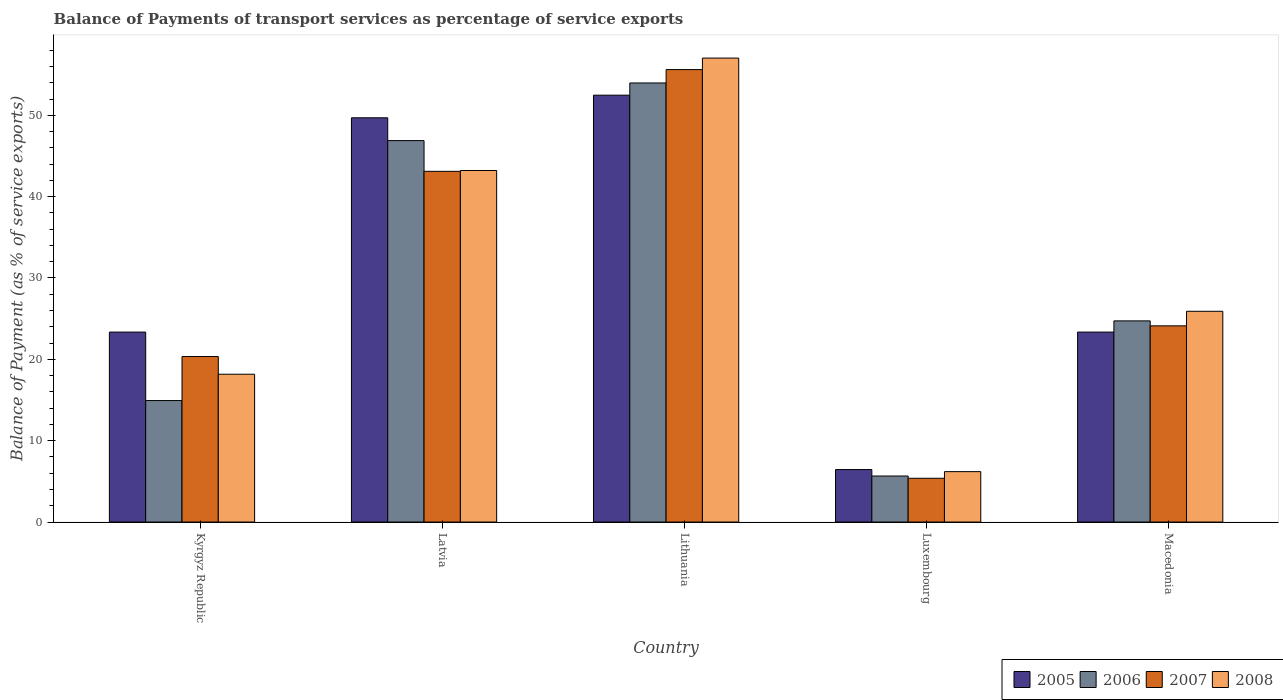How many different coloured bars are there?
Give a very brief answer. 4. How many groups of bars are there?
Your answer should be very brief. 5. Are the number of bars on each tick of the X-axis equal?
Ensure brevity in your answer.  Yes. How many bars are there on the 1st tick from the left?
Make the answer very short. 4. How many bars are there on the 3rd tick from the right?
Keep it short and to the point. 4. What is the label of the 3rd group of bars from the left?
Offer a very short reply. Lithuania. In how many cases, is the number of bars for a given country not equal to the number of legend labels?
Offer a very short reply. 0. What is the balance of payments of transport services in 2008 in Macedonia?
Your answer should be compact. 25.91. Across all countries, what is the maximum balance of payments of transport services in 2006?
Provide a short and direct response. 53.97. Across all countries, what is the minimum balance of payments of transport services in 2007?
Make the answer very short. 5.38. In which country was the balance of payments of transport services in 2008 maximum?
Ensure brevity in your answer.  Lithuania. In which country was the balance of payments of transport services in 2006 minimum?
Your response must be concise. Luxembourg. What is the total balance of payments of transport services in 2006 in the graph?
Provide a short and direct response. 146.18. What is the difference between the balance of payments of transport services in 2008 in Lithuania and that in Macedonia?
Your response must be concise. 31.13. What is the difference between the balance of payments of transport services in 2008 in Luxembourg and the balance of payments of transport services in 2005 in Kyrgyz Republic?
Make the answer very short. -17.15. What is the average balance of payments of transport services in 2005 per country?
Ensure brevity in your answer.  31.06. What is the difference between the balance of payments of transport services of/in 2007 and balance of payments of transport services of/in 2005 in Kyrgyz Republic?
Keep it short and to the point. -3. In how many countries, is the balance of payments of transport services in 2007 greater than 2 %?
Keep it short and to the point. 5. What is the ratio of the balance of payments of transport services in 2007 in Kyrgyz Republic to that in Latvia?
Give a very brief answer. 0.47. What is the difference between the highest and the second highest balance of payments of transport services in 2005?
Your answer should be compact. -2.78. What is the difference between the highest and the lowest balance of payments of transport services in 2007?
Your answer should be compact. 50.24. What does the 3rd bar from the left in Kyrgyz Republic represents?
Provide a short and direct response. 2007. How many bars are there?
Provide a succinct answer. 20. Are all the bars in the graph horizontal?
Your answer should be compact. No. How many countries are there in the graph?
Provide a succinct answer. 5. What is the difference between two consecutive major ticks on the Y-axis?
Your answer should be compact. 10. Are the values on the major ticks of Y-axis written in scientific E-notation?
Offer a terse response. No. How many legend labels are there?
Offer a terse response. 4. How are the legend labels stacked?
Give a very brief answer. Horizontal. What is the title of the graph?
Provide a short and direct response. Balance of Payments of transport services as percentage of service exports. What is the label or title of the X-axis?
Your answer should be compact. Country. What is the label or title of the Y-axis?
Offer a terse response. Balance of Payment (as % of service exports). What is the Balance of Payment (as % of service exports) in 2005 in Kyrgyz Republic?
Offer a very short reply. 23.35. What is the Balance of Payment (as % of service exports) of 2006 in Kyrgyz Republic?
Ensure brevity in your answer.  14.93. What is the Balance of Payment (as % of service exports) of 2007 in Kyrgyz Republic?
Make the answer very short. 20.34. What is the Balance of Payment (as % of service exports) of 2008 in Kyrgyz Republic?
Your answer should be compact. 18.17. What is the Balance of Payment (as % of service exports) in 2005 in Latvia?
Provide a short and direct response. 49.69. What is the Balance of Payment (as % of service exports) in 2006 in Latvia?
Provide a short and direct response. 46.89. What is the Balance of Payment (as % of service exports) in 2007 in Latvia?
Provide a short and direct response. 43.11. What is the Balance of Payment (as % of service exports) of 2008 in Latvia?
Make the answer very short. 43.21. What is the Balance of Payment (as % of service exports) in 2005 in Lithuania?
Offer a terse response. 52.47. What is the Balance of Payment (as % of service exports) of 2006 in Lithuania?
Offer a terse response. 53.97. What is the Balance of Payment (as % of service exports) of 2007 in Lithuania?
Make the answer very short. 55.62. What is the Balance of Payment (as % of service exports) in 2008 in Lithuania?
Your answer should be compact. 57.03. What is the Balance of Payment (as % of service exports) in 2005 in Luxembourg?
Your response must be concise. 6.45. What is the Balance of Payment (as % of service exports) of 2006 in Luxembourg?
Give a very brief answer. 5.66. What is the Balance of Payment (as % of service exports) in 2007 in Luxembourg?
Offer a terse response. 5.38. What is the Balance of Payment (as % of service exports) in 2008 in Luxembourg?
Offer a terse response. 6.2. What is the Balance of Payment (as % of service exports) of 2005 in Macedonia?
Offer a terse response. 23.35. What is the Balance of Payment (as % of service exports) in 2006 in Macedonia?
Your answer should be compact. 24.73. What is the Balance of Payment (as % of service exports) of 2007 in Macedonia?
Offer a very short reply. 24.12. What is the Balance of Payment (as % of service exports) in 2008 in Macedonia?
Your answer should be very brief. 25.91. Across all countries, what is the maximum Balance of Payment (as % of service exports) of 2005?
Your answer should be very brief. 52.47. Across all countries, what is the maximum Balance of Payment (as % of service exports) of 2006?
Your answer should be compact. 53.97. Across all countries, what is the maximum Balance of Payment (as % of service exports) of 2007?
Give a very brief answer. 55.62. Across all countries, what is the maximum Balance of Payment (as % of service exports) of 2008?
Offer a terse response. 57.03. Across all countries, what is the minimum Balance of Payment (as % of service exports) in 2005?
Offer a terse response. 6.45. Across all countries, what is the minimum Balance of Payment (as % of service exports) of 2006?
Your response must be concise. 5.66. Across all countries, what is the minimum Balance of Payment (as % of service exports) in 2007?
Your answer should be compact. 5.38. Across all countries, what is the minimum Balance of Payment (as % of service exports) in 2008?
Provide a succinct answer. 6.2. What is the total Balance of Payment (as % of service exports) of 2005 in the graph?
Your answer should be very brief. 155.31. What is the total Balance of Payment (as % of service exports) in 2006 in the graph?
Ensure brevity in your answer.  146.18. What is the total Balance of Payment (as % of service exports) of 2007 in the graph?
Your response must be concise. 148.57. What is the total Balance of Payment (as % of service exports) in 2008 in the graph?
Provide a succinct answer. 150.51. What is the difference between the Balance of Payment (as % of service exports) in 2005 in Kyrgyz Republic and that in Latvia?
Make the answer very short. -26.34. What is the difference between the Balance of Payment (as % of service exports) of 2006 in Kyrgyz Republic and that in Latvia?
Provide a succinct answer. -31.95. What is the difference between the Balance of Payment (as % of service exports) of 2007 in Kyrgyz Republic and that in Latvia?
Your answer should be very brief. -22.76. What is the difference between the Balance of Payment (as % of service exports) of 2008 in Kyrgyz Republic and that in Latvia?
Keep it short and to the point. -25.04. What is the difference between the Balance of Payment (as % of service exports) in 2005 in Kyrgyz Republic and that in Lithuania?
Your response must be concise. -29.12. What is the difference between the Balance of Payment (as % of service exports) of 2006 in Kyrgyz Republic and that in Lithuania?
Ensure brevity in your answer.  -39.04. What is the difference between the Balance of Payment (as % of service exports) of 2007 in Kyrgyz Republic and that in Lithuania?
Keep it short and to the point. -35.27. What is the difference between the Balance of Payment (as % of service exports) of 2008 in Kyrgyz Republic and that in Lithuania?
Keep it short and to the point. -38.86. What is the difference between the Balance of Payment (as % of service exports) of 2005 in Kyrgyz Republic and that in Luxembourg?
Ensure brevity in your answer.  16.9. What is the difference between the Balance of Payment (as % of service exports) of 2006 in Kyrgyz Republic and that in Luxembourg?
Offer a terse response. 9.28. What is the difference between the Balance of Payment (as % of service exports) in 2007 in Kyrgyz Republic and that in Luxembourg?
Ensure brevity in your answer.  14.97. What is the difference between the Balance of Payment (as % of service exports) in 2008 in Kyrgyz Republic and that in Luxembourg?
Your response must be concise. 11.97. What is the difference between the Balance of Payment (as % of service exports) of 2005 in Kyrgyz Republic and that in Macedonia?
Keep it short and to the point. -0. What is the difference between the Balance of Payment (as % of service exports) of 2006 in Kyrgyz Republic and that in Macedonia?
Offer a very short reply. -9.79. What is the difference between the Balance of Payment (as % of service exports) of 2007 in Kyrgyz Republic and that in Macedonia?
Ensure brevity in your answer.  -3.77. What is the difference between the Balance of Payment (as % of service exports) of 2008 in Kyrgyz Republic and that in Macedonia?
Give a very brief answer. -7.74. What is the difference between the Balance of Payment (as % of service exports) in 2005 in Latvia and that in Lithuania?
Make the answer very short. -2.78. What is the difference between the Balance of Payment (as % of service exports) in 2006 in Latvia and that in Lithuania?
Offer a very short reply. -7.09. What is the difference between the Balance of Payment (as % of service exports) in 2007 in Latvia and that in Lithuania?
Your answer should be very brief. -12.51. What is the difference between the Balance of Payment (as % of service exports) of 2008 in Latvia and that in Lithuania?
Give a very brief answer. -13.82. What is the difference between the Balance of Payment (as % of service exports) in 2005 in Latvia and that in Luxembourg?
Your response must be concise. 43.24. What is the difference between the Balance of Payment (as % of service exports) in 2006 in Latvia and that in Luxembourg?
Make the answer very short. 41.23. What is the difference between the Balance of Payment (as % of service exports) in 2007 in Latvia and that in Luxembourg?
Your response must be concise. 37.73. What is the difference between the Balance of Payment (as % of service exports) of 2008 in Latvia and that in Luxembourg?
Offer a very short reply. 37.02. What is the difference between the Balance of Payment (as % of service exports) of 2005 in Latvia and that in Macedonia?
Offer a terse response. 26.34. What is the difference between the Balance of Payment (as % of service exports) of 2006 in Latvia and that in Macedonia?
Offer a terse response. 22.16. What is the difference between the Balance of Payment (as % of service exports) in 2007 in Latvia and that in Macedonia?
Provide a short and direct response. 18.99. What is the difference between the Balance of Payment (as % of service exports) of 2008 in Latvia and that in Macedonia?
Make the answer very short. 17.31. What is the difference between the Balance of Payment (as % of service exports) of 2005 in Lithuania and that in Luxembourg?
Your answer should be compact. 46.02. What is the difference between the Balance of Payment (as % of service exports) in 2006 in Lithuania and that in Luxembourg?
Ensure brevity in your answer.  48.32. What is the difference between the Balance of Payment (as % of service exports) of 2007 in Lithuania and that in Luxembourg?
Your answer should be very brief. 50.24. What is the difference between the Balance of Payment (as % of service exports) of 2008 in Lithuania and that in Luxembourg?
Your answer should be very brief. 50.84. What is the difference between the Balance of Payment (as % of service exports) of 2005 in Lithuania and that in Macedonia?
Offer a very short reply. 29.12. What is the difference between the Balance of Payment (as % of service exports) of 2006 in Lithuania and that in Macedonia?
Provide a short and direct response. 29.25. What is the difference between the Balance of Payment (as % of service exports) in 2007 in Lithuania and that in Macedonia?
Give a very brief answer. 31.5. What is the difference between the Balance of Payment (as % of service exports) of 2008 in Lithuania and that in Macedonia?
Ensure brevity in your answer.  31.13. What is the difference between the Balance of Payment (as % of service exports) in 2005 in Luxembourg and that in Macedonia?
Your answer should be compact. -16.9. What is the difference between the Balance of Payment (as % of service exports) in 2006 in Luxembourg and that in Macedonia?
Offer a very short reply. -19.07. What is the difference between the Balance of Payment (as % of service exports) in 2007 in Luxembourg and that in Macedonia?
Give a very brief answer. -18.74. What is the difference between the Balance of Payment (as % of service exports) of 2008 in Luxembourg and that in Macedonia?
Your answer should be compact. -19.71. What is the difference between the Balance of Payment (as % of service exports) in 2005 in Kyrgyz Republic and the Balance of Payment (as % of service exports) in 2006 in Latvia?
Offer a terse response. -23.54. What is the difference between the Balance of Payment (as % of service exports) of 2005 in Kyrgyz Republic and the Balance of Payment (as % of service exports) of 2007 in Latvia?
Offer a very short reply. -19.76. What is the difference between the Balance of Payment (as % of service exports) of 2005 in Kyrgyz Republic and the Balance of Payment (as % of service exports) of 2008 in Latvia?
Keep it short and to the point. -19.86. What is the difference between the Balance of Payment (as % of service exports) in 2006 in Kyrgyz Republic and the Balance of Payment (as % of service exports) in 2007 in Latvia?
Your answer should be very brief. -28.18. What is the difference between the Balance of Payment (as % of service exports) in 2006 in Kyrgyz Republic and the Balance of Payment (as % of service exports) in 2008 in Latvia?
Provide a short and direct response. -28.28. What is the difference between the Balance of Payment (as % of service exports) in 2007 in Kyrgyz Republic and the Balance of Payment (as % of service exports) in 2008 in Latvia?
Your answer should be compact. -22.87. What is the difference between the Balance of Payment (as % of service exports) of 2005 in Kyrgyz Republic and the Balance of Payment (as % of service exports) of 2006 in Lithuania?
Offer a very short reply. -30.62. What is the difference between the Balance of Payment (as % of service exports) in 2005 in Kyrgyz Republic and the Balance of Payment (as % of service exports) in 2007 in Lithuania?
Offer a terse response. -32.27. What is the difference between the Balance of Payment (as % of service exports) in 2005 in Kyrgyz Republic and the Balance of Payment (as % of service exports) in 2008 in Lithuania?
Provide a short and direct response. -33.68. What is the difference between the Balance of Payment (as % of service exports) in 2006 in Kyrgyz Republic and the Balance of Payment (as % of service exports) in 2007 in Lithuania?
Your answer should be very brief. -40.68. What is the difference between the Balance of Payment (as % of service exports) in 2006 in Kyrgyz Republic and the Balance of Payment (as % of service exports) in 2008 in Lithuania?
Give a very brief answer. -42.1. What is the difference between the Balance of Payment (as % of service exports) in 2007 in Kyrgyz Republic and the Balance of Payment (as % of service exports) in 2008 in Lithuania?
Make the answer very short. -36.69. What is the difference between the Balance of Payment (as % of service exports) in 2005 in Kyrgyz Republic and the Balance of Payment (as % of service exports) in 2006 in Luxembourg?
Give a very brief answer. 17.69. What is the difference between the Balance of Payment (as % of service exports) of 2005 in Kyrgyz Republic and the Balance of Payment (as % of service exports) of 2007 in Luxembourg?
Keep it short and to the point. 17.97. What is the difference between the Balance of Payment (as % of service exports) of 2005 in Kyrgyz Republic and the Balance of Payment (as % of service exports) of 2008 in Luxembourg?
Your response must be concise. 17.15. What is the difference between the Balance of Payment (as % of service exports) of 2006 in Kyrgyz Republic and the Balance of Payment (as % of service exports) of 2007 in Luxembourg?
Offer a terse response. 9.55. What is the difference between the Balance of Payment (as % of service exports) in 2006 in Kyrgyz Republic and the Balance of Payment (as % of service exports) in 2008 in Luxembourg?
Your response must be concise. 8.74. What is the difference between the Balance of Payment (as % of service exports) of 2007 in Kyrgyz Republic and the Balance of Payment (as % of service exports) of 2008 in Luxembourg?
Provide a succinct answer. 14.15. What is the difference between the Balance of Payment (as % of service exports) in 2005 in Kyrgyz Republic and the Balance of Payment (as % of service exports) in 2006 in Macedonia?
Your answer should be compact. -1.38. What is the difference between the Balance of Payment (as % of service exports) in 2005 in Kyrgyz Republic and the Balance of Payment (as % of service exports) in 2007 in Macedonia?
Keep it short and to the point. -0.77. What is the difference between the Balance of Payment (as % of service exports) of 2005 in Kyrgyz Republic and the Balance of Payment (as % of service exports) of 2008 in Macedonia?
Keep it short and to the point. -2.56. What is the difference between the Balance of Payment (as % of service exports) of 2006 in Kyrgyz Republic and the Balance of Payment (as % of service exports) of 2007 in Macedonia?
Ensure brevity in your answer.  -9.18. What is the difference between the Balance of Payment (as % of service exports) of 2006 in Kyrgyz Republic and the Balance of Payment (as % of service exports) of 2008 in Macedonia?
Offer a very short reply. -10.97. What is the difference between the Balance of Payment (as % of service exports) in 2007 in Kyrgyz Republic and the Balance of Payment (as % of service exports) in 2008 in Macedonia?
Provide a succinct answer. -5.56. What is the difference between the Balance of Payment (as % of service exports) of 2005 in Latvia and the Balance of Payment (as % of service exports) of 2006 in Lithuania?
Your answer should be very brief. -4.28. What is the difference between the Balance of Payment (as % of service exports) of 2005 in Latvia and the Balance of Payment (as % of service exports) of 2007 in Lithuania?
Your answer should be compact. -5.93. What is the difference between the Balance of Payment (as % of service exports) in 2005 in Latvia and the Balance of Payment (as % of service exports) in 2008 in Lithuania?
Offer a terse response. -7.34. What is the difference between the Balance of Payment (as % of service exports) in 2006 in Latvia and the Balance of Payment (as % of service exports) in 2007 in Lithuania?
Offer a terse response. -8.73. What is the difference between the Balance of Payment (as % of service exports) of 2006 in Latvia and the Balance of Payment (as % of service exports) of 2008 in Lithuania?
Offer a very short reply. -10.14. What is the difference between the Balance of Payment (as % of service exports) of 2007 in Latvia and the Balance of Payment (as % of service exports) of 2008 in Lithuania?
Make the answer very short. -13.92. What is the difference between the Balance of Payment (as % of service exports) of 2005 in Latvia and the Balance of Payment (as % of service exports) of 2006 in Luxembourg?
Ensure brevity in your answer.  44.04. What is the difference between the Balance of Payment (as % of service exports) in 2005 in Latvia and the Balance of Payment (as % of service exports) in 2007 in Luxembourg?
Your answer should be very brief. 44.31. What is the difference between the Balance of Payment (as % of service exports) of 2005 in Latvia and the Balance of Payment (as % of service exports) of 2008 in Luxembourg?
Provide a succinct answer. 43.5. What is the difference between the Balance of Payment (as % of service exports) of 2006 in Latvia and the Balance of Payment (as % of service exports) of 2007 in Luxembourg?
Your answer should be very brief. 41.51. What is the difference between the Balance of Payment (as % of service exports) of 2006 in Latvia and the Balance of Payment (as % of service exports) of 2008 in Luxembourg?
Ensure brevity in your answer.  40.69. What is the difference between the Balance of Payment (as % of service exports) in 2007 in Latvia and the Balance of Payment (as % of service exports) in 2008 in Luxembourg?
Provide a short and direct response. 36.91. What is the difference between the Balance of Payment (as % of service exports) of 2005 in Latvia and the Balance of Payment (as % of service exports) of 2006 in Macedonia?
Keep it short and to the point. 24.96. What is the difference between the Balance of Payment (as % of service exports) of 2005 in Latvia and the Balance of Payment (as % of service exports) of 2007 in Macedonia?
Ensure brevity in your answer.  25.58. What is the difference between the Balance of Payment (as % of service exports) in 2005 in Latvia and the Balance of Payment (as % of service exports) in 2008 in Macedonia?
Make the answer very short. 23.79. What is the difference between the Balance of Payment (as % of service exports) in 2006 in Latvia and the Balance of Payment (as % of service exports) in 2007 in Macedonia?
Make the answer very short. 22.77. What is the difference between the Balance of Payment (as % of service exports) in 2006 in Latvia and the Balance of Payment (as % of service exports) in 2008 in Macedonia?
Give a very brief answer. 20.98. What is the difference between the Balance of Payment (as % of service exports) in 2007 in Latvia and the Balance of Payment (as % of service exports) in 2008 in Macedonia?
Keep it short and to the point. 17.2. What is the difference between the Balance of Payment (as % of service exports) in 2005 in Lithuania and the Balance of Payment (as % of service exports) in 2006 in Luxembourg?
Provide a succinct answer. 46.82. What is the difference between the Balance of Payment (as % of service exports) in 2005 in Lithuania and the Balance of Payment (as % of service exports) in 2007 in Luxembourg?
Offer a very short reply. 47.09. What is the difference between the Balance of Payment (as % of service exports) of 2005 in Lithuania and the Balance of Payment (as % of service exports) of 2008 in Luxembourg?
Your response must be concise. 46.27. What is the difference between the Balance of Payment (as % of service exports) of 2006 in Lithuania and the Balance of Payment (as % of service exports) of 2007 in Luxembourg?
Make the answer very short. 48.59. What is the difference between the Balance of Payment (as % of service exports) of 2006 in Lithuania and the Balance of Payment (as % of service exports) of 2008 in Luxembourg?
Your answer should be compact. 47.78. What is the difference between the Balance of Payment (as % of service exports) in 2007 in Lithuania and the Balance of Payment (as % of service exports) in 2008 in Luxembourg?
Your response must be concise. 49.42. What is the difference between the Balance of Payment (as % of service exports) of 2005 in Lithuania and the Balance of Payment (as % of service exports) of 2006 in Macedonia?
Ensure brevity in your answer.  27.74. What is the difference between the Balance of Payment (as % of service exports) of 2005 in Lithuania and the Balance of Payment (as % of service exports) of 2007 in Macedonia?
Provide a short and direct response. 28.36. What is the difference between the Balance of Payment (as % of service exports) of 2005 in Lithuania and the Balance of Payment (as % of service exports) of 2008 in Macedonia?
Your answer should be very brief. 26.57. What is the difference between the Balance of Payment (as % of service exports) of 2006 in Lithuania and the Balance of Payment (as % of service exports) of 2007 in Macedonia?
Offer a very short reply. 29.86. What is the difference between the Balance of Payment (as % of service exports) in 2006 in Lithuania and the Balance of Payment (as % of service exports) in 2008 in Macedonia?
Offer a very short reply. 28.07. What is the difference between the Balance of Payment (as % of service exports) in 2007 in Lithuania and the Balance of Payment (as % of service exports) in 2008 in Macedonia?
Make the answer very short. 29.71. What is the difference between the Balance of Payment (as % of service exports) of 2005 in Luxembourg and the Balance of Payment (as % of service exports) of 2006 in Macedonia?
Keep it short and to the point. -18.28. What is the difference between the Balance of Payment (as % of service exports) of 2005 in Luxembourg and the Balance of Payment (as % of service exports) of 2007 in Macedonia?
Your response must be concise. -17.66. What is the difference between the Balance of Payment (as % of service exports) in 2005 in Luxembourg and the Balance of Payment (as % of service exports) in 2008 in Macedonia?
Provide a short and direct response. -19.45. What is the difference between the Balance of Payment (as % of service exports) of 2006 in Luxembourg and the Balance of Payment (as % of service exports) of 2007 in Macedonia?
Your answer should be very brief. -18.46. What is the difference between the Balance of Payment (as % of service exports) of 2006 in Luxembourg and the Balance of Payment (as % of service exports) of 2008 in Macedonia?
Your response must be concise. -20.25. What is the difference between the Balance of Payment (as % of service exports) of 2007 in Luxembourg and the Balance of Payment (as % of service exports) of 2008 in Macedonia?
Offer a terse response. -20.53. What is the average Balance of Payment (as % of service exports) in 2005 per country?
Offer a very short reply. 31.06. What is the average Balance of Payment (as % of service exports) in 2006 per country?
Your response must be concise. 29.24. What is the average Balance of Payment (as % of service exports) in 2007 per country?
Provide a succinct answer. 29.71. What is the average Balance of Payment (as % of service exports) of 2008 per country?
Make the answer very short. 30.1. What is the difference between the Balance of Payment (as % of service exports) in 2005 and Balance of Payment (as % of service exports) in 2006 in Kyrgyz Republic?
Offer a terse response. 8.42. What is the difference between the Balance of Payment (as % of service exports) in 2005 and Balance of Payment (as % of service exports) in 2007 in Kyrgyz Republic?
Offer a very short reply. 3. What is the difference between the Balance of Payment (as % of service exports) in 2005 and Balance of Payment (as % of service exports) in 2008 in Kyrgyz Republic?
Provide a succinct answer. 5.18. What is the difference between the Balance of Payment (as % of service exports) of 2006 and Balance of Payment (as % of service exports) of 2007 in Kyrgyz Republic?
Provide a succinct answer. -5.41. What is the difference between the Balance of Payment (as % of service exports) in 2006 and Balance of Payment (as % of service exports) in 2008 in Kyrgyz Republic?
Offer a terse response. -3.24. What is the difference between the Balance of Payment (as % of service exports) in 2007 and Balance of Payment (as % of service exports) in 2008 in Kyrgyz Republic?
Make the answer very short. 2.18. What is the difference between the Balance of Payment (as % of service exports) of 2005 and Balance of Payment (as % of service exports) of 2006 in Latvia?
Ensure brevity in your answer.  2.8. What is the difference between the Balance of Payment (as % of service exports) of 2005 and Balance of Payment (as % of service exports) of 2007 in Latvia?
Your answer should be very brief. 6.58. What is the difference between the Balance of Payment (as % of service exports) in 2005 and Balance of Payment (as % of service exports) in 2008 in Latvia?
Keep it short and to the point. 6.48. What is the difference between the Balance of Payment (as % of service exports) in 2006 and Balance of Payment (as % of service exports) in 2007 in Latvia?
Offer a terse response. 3.78. What is the difference between the Balance of Payment (as % of service exports) in 2006 and Balance of Payment (as % of service exports) in 2008 in Latvia?
Provide a short and direct response. 3.67. What is the difference between the Balance of Payment (as % of service exports) in 2007 and Balance of Payment (as % of service exports) in 2008 in Latvia?
Your answer should be very brief. -0.1. What is the difference between the Balance of Payment (as % of service exports) in 2005 and Balance of Payment (as % of service exports) in 2006 in Lithuania?
Your response must be concise. -1.5. What is the difference between the Balance of Payment (as % of service exports) of 2005 and Balance of Payment (as % of service exports) of 2007 in Lithuania?
Your response must be concise. -3.15. What is the difference between the Balance of Payment (as % of service exports) in 2005 and Balance of Payment (as % of service exports) in 2008 in Lithuania?
Your answer should be very brief. -4.56. What is the difference between the Balance of Payment (as % of service exports) in 2006 and Balance of Payment (as % of service exports) in 2007 in Lithuania?
Make the answer very short. -1.64. What is the difference between the Balance of Payment (as % of service exports) in 2006 and Balance of Payment (as % of service exports) in 2008 in Lithuania?
Give a very brief answer. -3.06. What is the difference between the Balance of Payment (as % of service exports) in 2007 and Balance of Payment (as % of service exports) in 2008 in Lithuania?
Your answer should be very brief. -1.41. What is the difference between the Balance of Payment (as % of service exports) of 2005 and Balance of Payment (as % of service exports) of 2006 in Luxembourg?
Make the answer very short. 0.8. What is the difference between the Balance of Payment (as % of service exports) in 2005 and Balance of Payment (as % of service exports) in 2007 in Luxembourg?
Offer a very short reply. 1.07. What is the difference between the Balance of Payment (as % of service exports) of 2005 and Balance of Payment (as % of service exports) of 2008 in Luxembourg?
Keep it short and to the point. 0.26. What is the difference between the Balance of Payment (as % of service exports) of 2006 and Balance of Payment (as % of service exports) of 2007 in Luxembourg?
Keep it short and to the point. 0.28. What is the difference between the Balance of Payment (as % of service exports) of 2006 and Balance of Payment (as % of service exports) of 2008 in Luxembourg?
Keep it short and to the point. -0.54. What is the difference between the Balance of Payment (as % of service exports) of 2007 and Balance of Payment (as % of service exports) of 2008 in Luxembourg?
Your answer should be compact. -0.82. What is the difference between the Balance of Payment (as % of service exports) in 2005 and Balance of Payment (as % of service exports) in 2006 in Macedonia?
Your answer should be compact. -1.38. What is the difference between the Balance of Payment (as % of service exports) of 2005 and Balance of Payment (as % of service exports) of 2007 in Macedonia?
Give a very brief answer. -0.76. What is the difference between the Balance of Payment (as % of service exports) in 2005 and Balance of Payment (as % of service exports) in 2008 in Macedonia?
Keep it short and to the point. -2.55. What is the difference between the Balance of Payment (as % of service exports) in 2006 and Balance of Payment (as % of service exports) in 2007 in Macedonia?
Keep it short and to the point. 0.61. What is the difference between the Balance of Payment (as % of service exports) in 2006 and Balance of Payment (as % of service exports) in 2008 in Macedonia?
Your answer should be compact. -1.18. What is the difference between the Balance of Payment (as % of service exports) of 2007 and Balance of Payment (as % of service exports) of 2008 in Macedonia?
Provide a succinct answer. -1.79. What is the ratio of the Balance of Payment (as % of service exports) in 2005 in Kyrgyz Republic to that in Latvia?
Provide a short and direct response. 0.47. What is the ratio of the Balance of Payment (as % of service exports) in 2006 in Kyrgyz Republic to that in Latvia?
Provide a short and direct response. 0.32. What is the ratio of the Balance of Payment (as % of service exports) of 2007 in Kyrgyz Republic to that in Latvia?
Provide a short and direct response. 0.47. What is the ratio of the Balance of Payment (as % of service exports) of 2008 in Kyrgyz Republic to that in Latvia?
Provide a short and direct response. 0.42. What is the ratio of the Balance of Payment (as % of service exports) in 2005 in Kyrgyz Republic to that in Lithuania?
Provide a short and direct response. 0.45. What is the ratio of the Balance of Payment (as % of service exports) in 2006 in Kyrgyz Republic to that in Lithuania?
Offer a very short reply. 0.28. What is the ratio of the Balance of Payment (as % of service exports) of 2007 in Kyrgyz Republic to that in Lithuania?
Keep it short and to the point. 0.37. What is the ratio of the Balance of Payment (as % of service exports) in 2008 in Kyrgyz Republic to that in Lithuania?
Provide a short and direct response. 0.32. What is the ratio of the Balance of Payment (as % of service exports) in 2005 in Kyrgyz Republic to that in Luxembourg?
Your response must be concise. 3.62. What is the ratio of the Balance of Payment (as % of service exports) in 2006 in Kyrgyz Republic to that in Luxembourg?
Ensure brevity in your answer.  2.64. What is the ratio of the Balance of Payment (as % of service exports) of 2007 in Kyrgyz Republic to that in Luxembourg?
Keep it short and to the point. 3.78. What is the ratio of the Balance of Payment (as % of service exports) of 2008 in Kyrgyz Republic to that in Luxembourg?
Make the answer very short. 2.93. What is the ratio of the Balance of Payment (as % of service exports) of 2005 in Kyrgyz Republic to that in Macedonia?
Keep it short and to the point. 1. What is the ratio of the Balance of Payment (as % of service exports) of 2006 in Kyrgyz Republic to that in Macedonia?
Offer a very short reply. 0.6. What is the ratio of the Balance of Payment (as % of service exports) of 2007 in Kyrgyz Republic to that in Macedonia?
Offer a terse response. 0.84. What is the ratio of the Balance of Payment (as % of service exports) in 2008 in Kyrgyz Republic to that in Macedonia?
Give a very brief answer. 0.7. What is the ratio of the Balance of Payment (as % of service exports) in 2005 in Latvia to that in Lithuania?
Make the answer very short. 0.95. What is the ratio of the Balance of Payment (as % of service exports) in 2006 in Latvia to that in Lithuania?
Make the answer very short. 0.87. What is the ratio of the Balance of Payment (as % of service exports) in 2007 in Latvia to that in Lithuania?
Your answer should be very brief. 0.78. What is the ratio of the Balance of Payment (as % of service exports) in 2008 in Latvia to that in Lithuania?
Offer a very short reply. 0.76. What is the ratio of the Balance of Payment (as % of service exports) in 2005 in Latvia to that in Luxembourg?
Keep it short and to the point. 7.7. What is the ratio of the Balance of Payment (as % of service exports) in 2006 in Latvia to that in Luxembourg?
Offer a terse response. 8.29. What is the ratio of the Balance of Payment (as % of service exports) in 2007 in Latvia to that in Luxembourg?
Ensure brevity in your answer.  8.01. What is the ratio of the Balance of Payment (as % of service exports) of 2008 in Latvia to that in Luxembourg?
Provide a short and direct response. 6.97. What is the ratio of the Balance of Payment (as % of service exports) in 2005 in Latvia to that in Macedonia?
Offer a very short reply. 2.13. What is the ratio of the Balance of Payment (as % of service exports) in 2006 in Latvia to that in Macedonia?
Make the answer very short. 1.9. What is the ratio of the Balance of Payment (as % of service exports) in 2007 in Latvia to that in Macedonia?
Provide a short and direct response. 1.79. What is the ratio of the Balance of Payment (as % of service exports) of 2008 in Latvia to that in Macedonia?
Ensure brevity in your answer.  1.67. What is the ratio of the Balance of Payment (as % of service exports) in 2005 in Lithuania to that in Luxembourg?
Provide a succinct answer. 8.13. What is the ratio of the Balance of Payment (as % of service exports) of 2006 in Lithuania to that in Luxembourg?
Your answer should be very brief. 9.54. What is the ratio of the Balance of Payment (as % of service exports) in 2007 in Lithuania to that in Luxembourg?
Keep it short and to the point. 10.34. What is the ratio of the Balance of Payment (as % of service exports) in 2008 in Lithuania to that in Luxembourg?
Make the answer very short. 9.2. What is the ratio of the Balance of Payment (as % of service exports) in 2005 in Lithuania to that in Macedonia?
Offer a very short reply. 2.25. What is the ratio of the Balance of Payment (as % of service exports) in 2006 in Lithuania to that in Macedonia?
Your answer should be very brief. 2.18. What is the ratio of the Balance of Payment (as % of service exports) in 2007 in Lithuania to that in Macedonia?
Keep it short and to the point. 2.31. What is the ratio of the Balance of Payment (as % of service exports) of 2008 in Lithuania to that in Macedonia?
Offer a very short reply. 2.2. What is the ratio of the Balance of Payment (as % of service exports) in 2005 in Luxembourg to that in Macedonia?
Your answer should be very brief. 0.28. What is the ratio of the Balance of Payment (as % of service exports) in 2006 in Luxembourg to that in Macedonia?
Provide a succinct answer. 0.23. What is the ratio of the Balance of Payment (as % of service exports) of 2007 in Luxembourg to that in Macedonia?
Ensure brevity in your answer.  0.22. What is the ratio of the Balance of Payment (as % of service exports) of 2008 in Luxembourg to that in Macedonia?
Offer a very short reply. 0.24. What is the difference between the highest and the second highest Balance of Payment (as % of service exports) in 2005?
Offer a very short reply. 2.78. What is the difference between the highest and the second highest Balance of Payment (as % of service exports) in 2006?
Make the answer very short. 7.09. What is the difference between the highest and the second highest Balance of Payment (as % of service exports) in 2007?
Make the answer very short. 12.51. What is the difference between the highest and the second highest Balance of Payment (as % of service exports) in 2008?
Ensure brevity in your answer.  13.82. What is the difference between the highest and the lowest Balance of Payment (as % of service exports) of 2005?
Your answer should be compact. 46.02. What is the difference between the highest and the lowest Balance of Payment (as % of service exports) of 2006?
Provide a short and direct response. 48.32. What is the difference between the highest and the lowest Balance of Payment (as % of service exports) in 2007?
Your answer should be very brief. 50.24. What is the difference between the highest and the lowest Balance of Payment (as % of service exports) of 2008?
Provide a short and direct response. 50.84. 